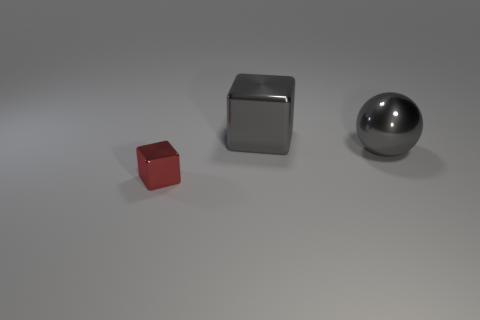If these objects were part of a simple game, what sort of game could it be? Imagining a creative use for these objects in a game, one could envisage a sorting challenge. The goal might be to position objects based on material type, or arrange them in order of size or reflectivity under a time constraint. The simplicity of their shapes and distinct materials can foster quick visual recognition and decision-making in such a hypothetical game. 